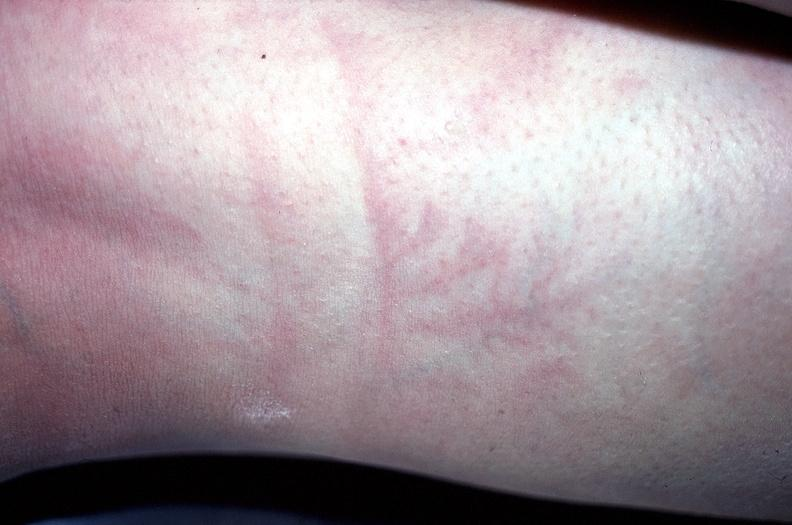what does this image show?
Answer the question using a single word or phrase. Arm 